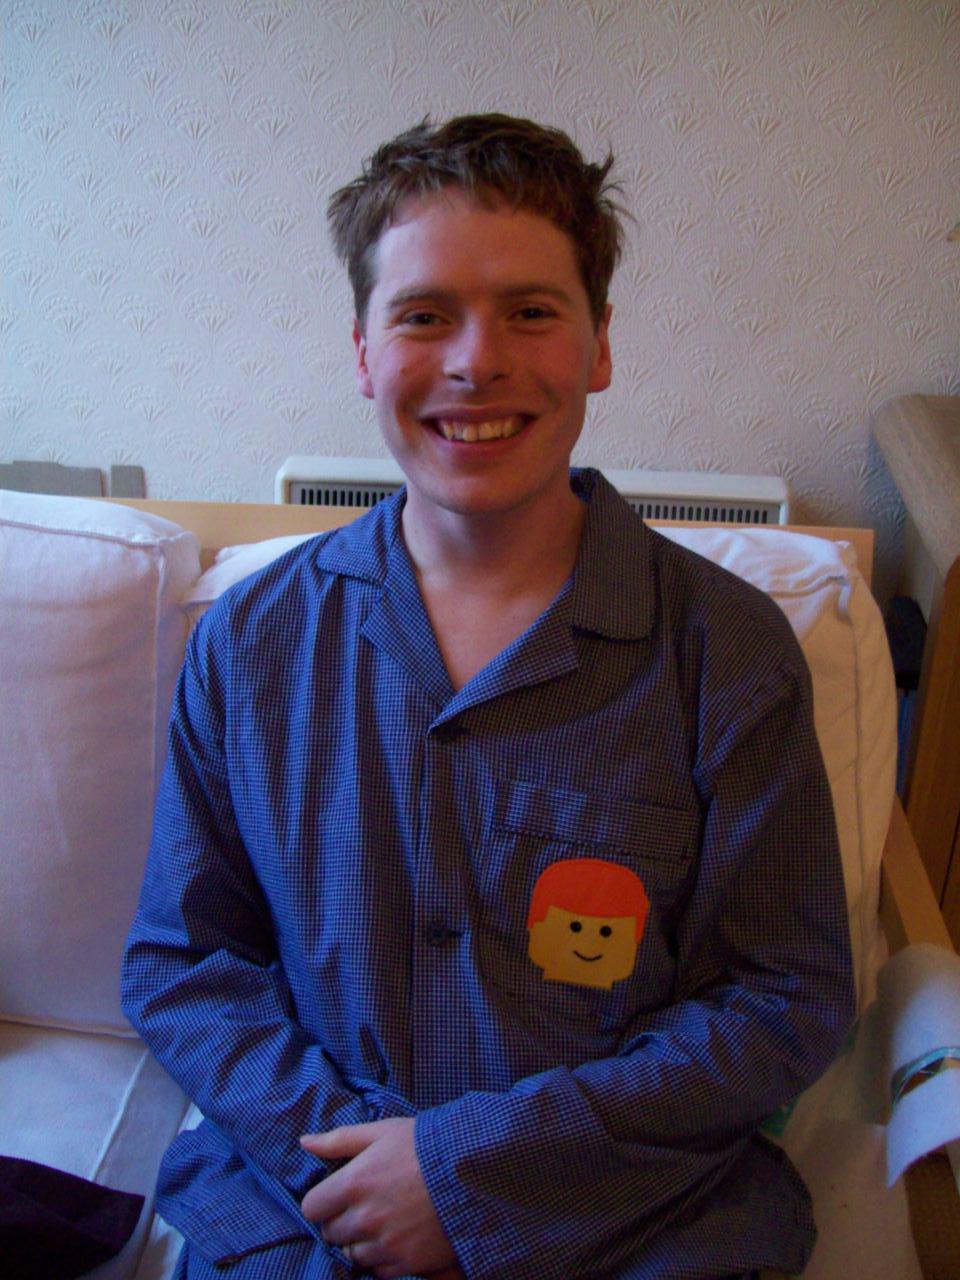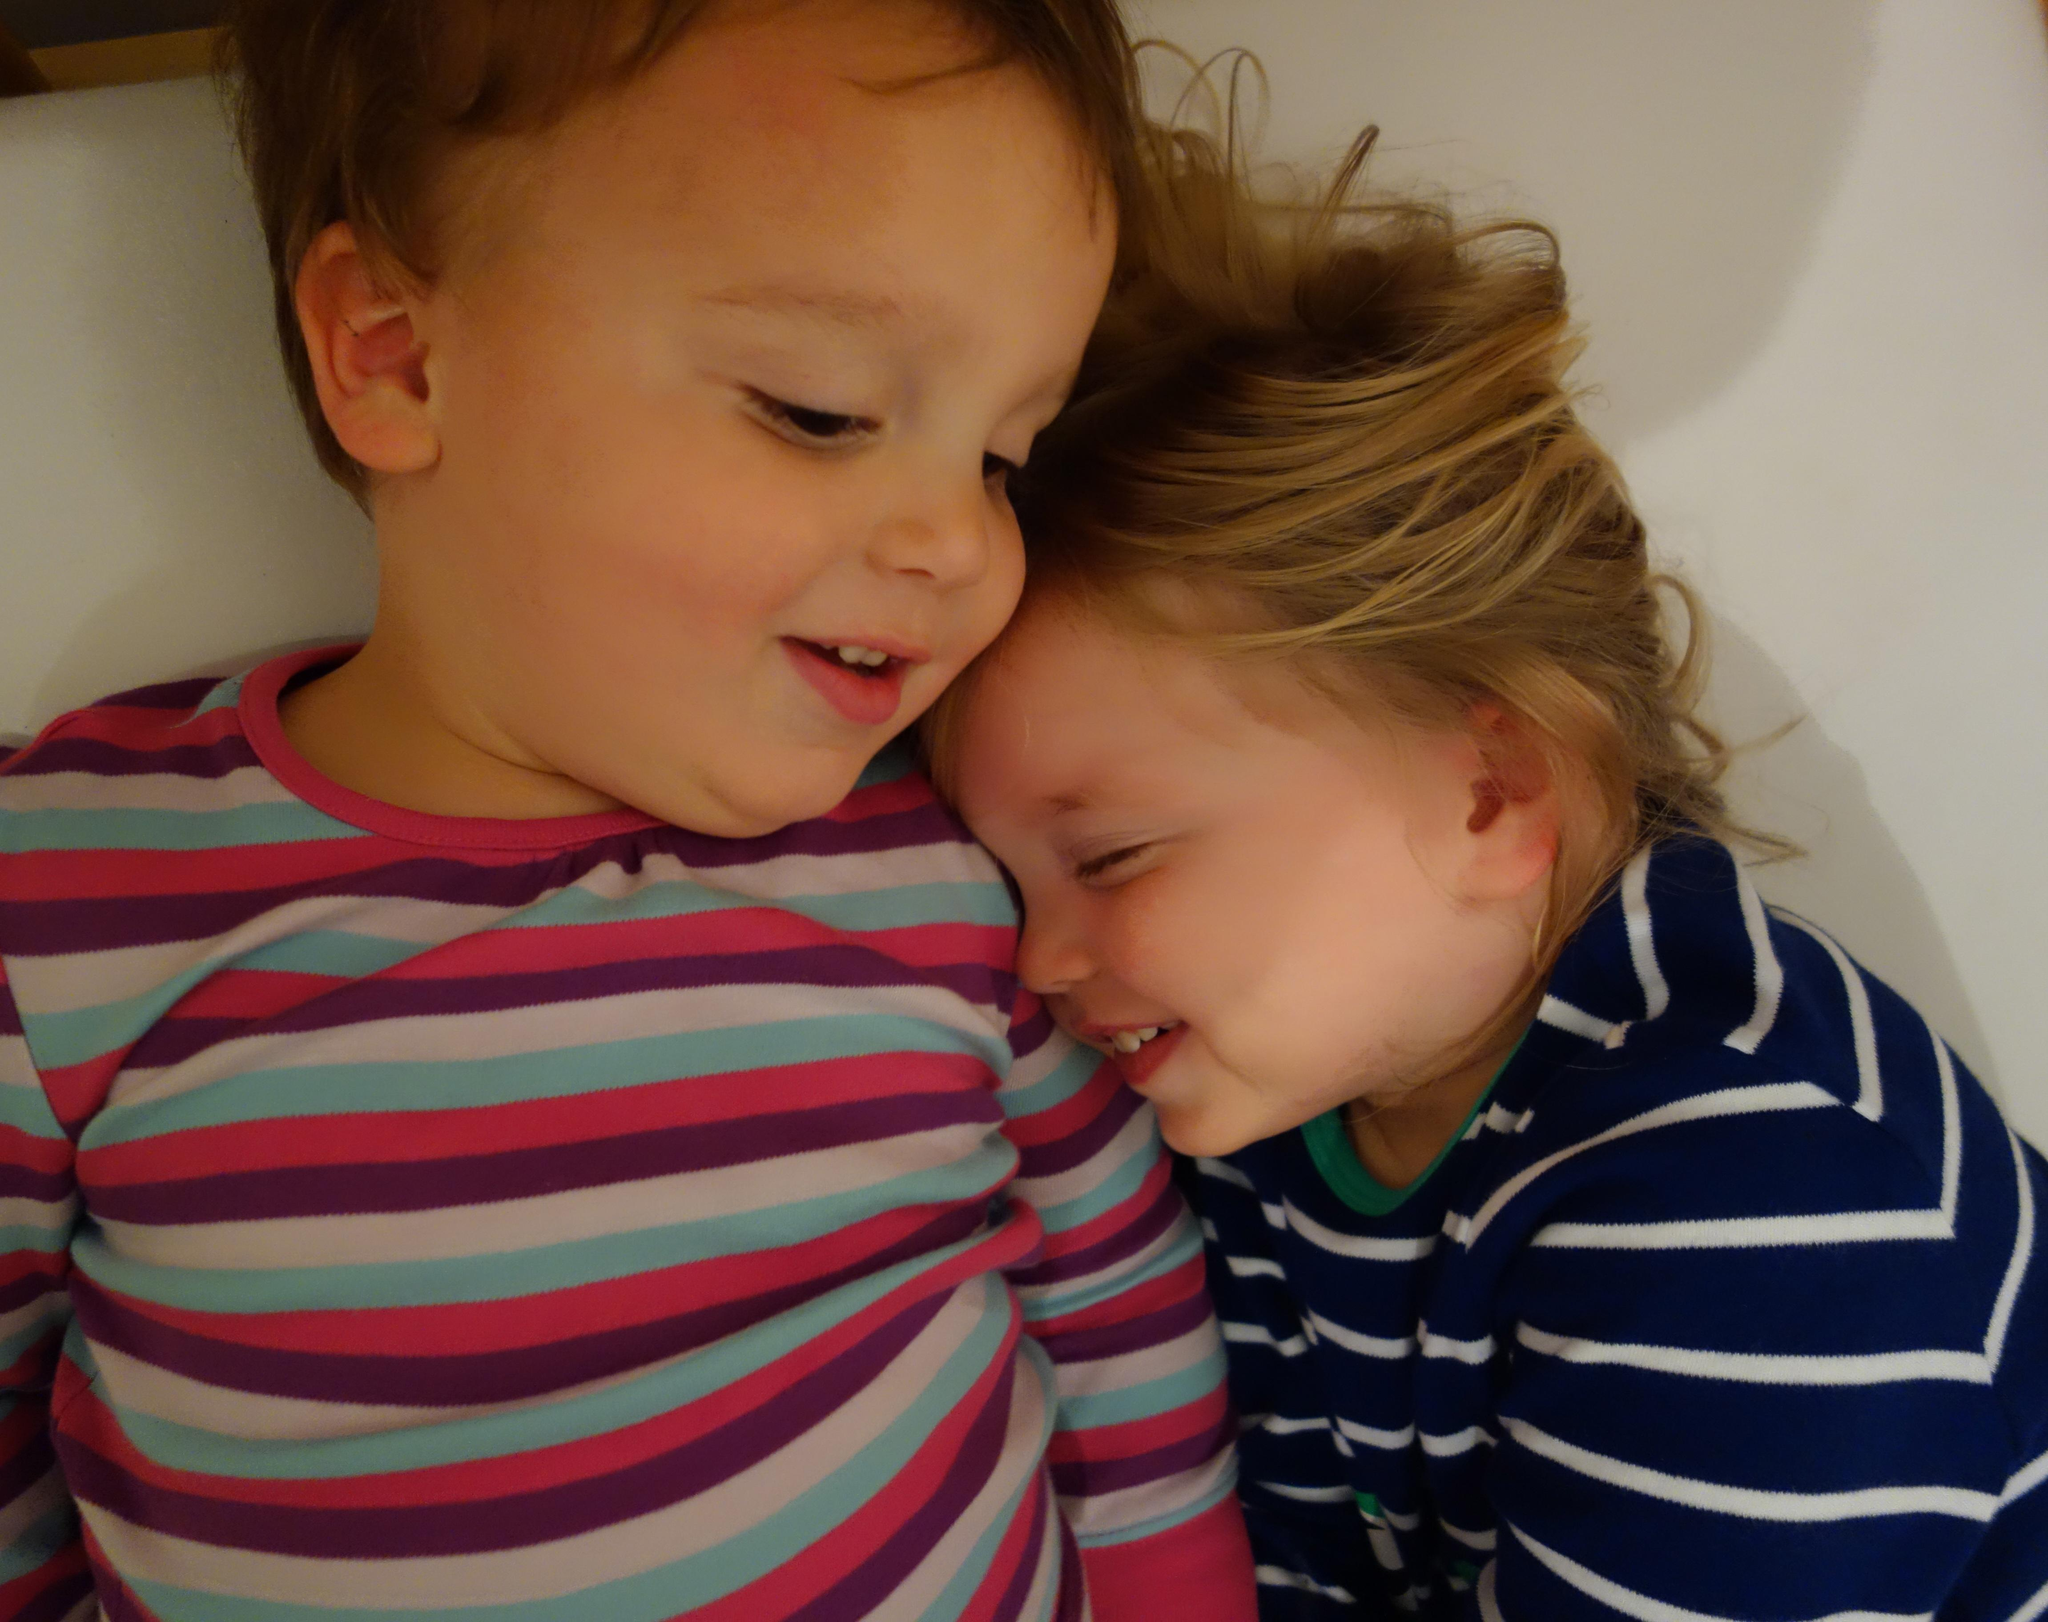The first image is the image on the left, the second image is the image on the right. Evaluate the accuracy of this statement regarding the images: "One of the images has both a boy and a girl.". Is it true? Answer yes or no. Yes. The first image is the image on the left, the second image is the image on the right. Evaluate the accuracy of this statement regarding the images: "One image has an adult with a kid in their lap.". Is it true? Answer yes or no. No. 